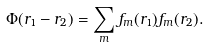<formula> <loc_0><loc_0><loc_500><loc_500>\Phi ( { r } _ { 1 } - { r } _ { 2 } ) = \sum _ { m } f _ { m } ( { r } _ { 1 } ) f _ { m } ( { r } _ { 2 } ) .</formula> 